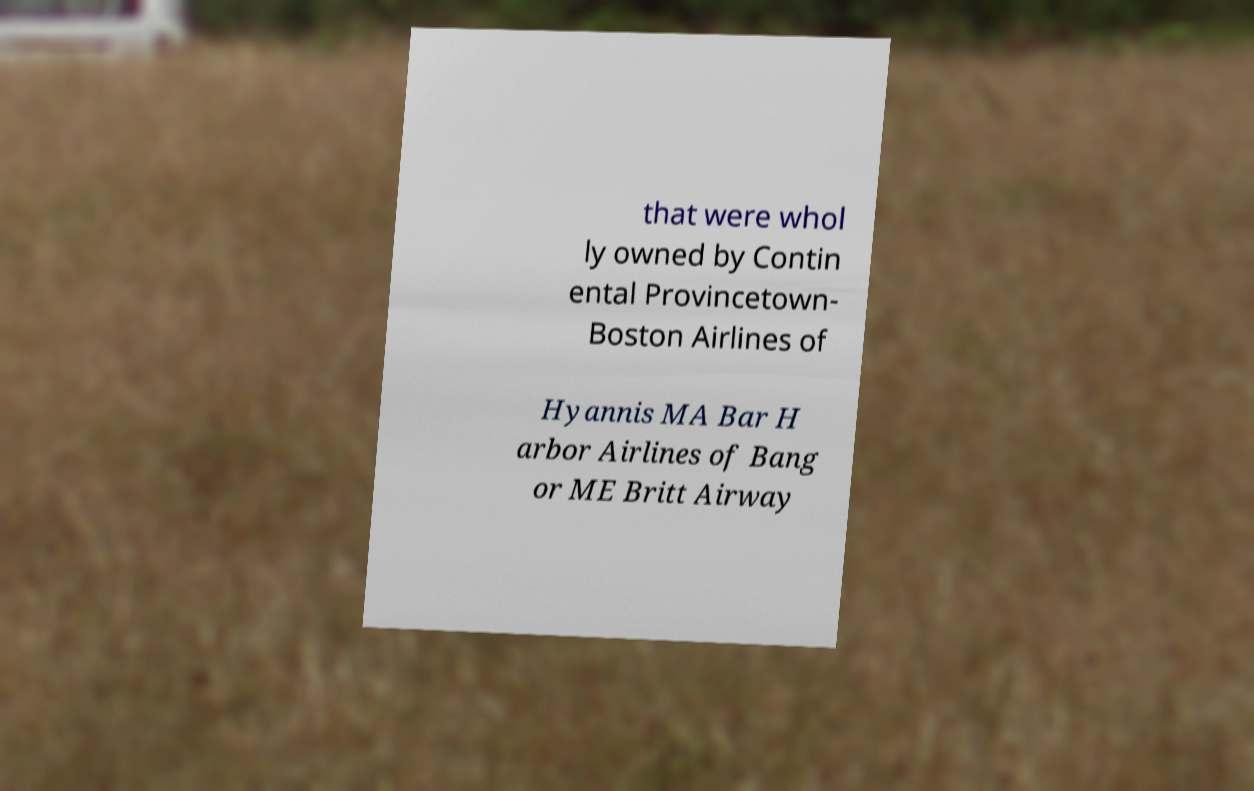Could you assist in decoding the text presented in this image and type it out clearly? that were whol ly owned by Contin ental Provincetown- Boston Airlines of Hyannis MA Bar H arbor Airlines of Bang or ME Britt Airway 